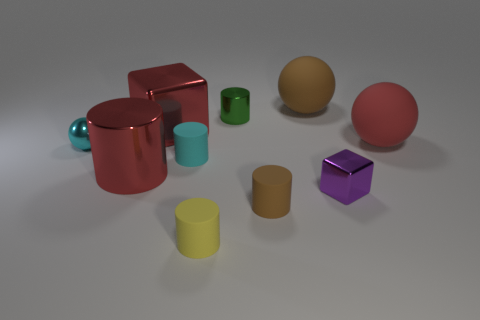Subtract all cyan cylinders. How many cylinders are left? 4 Subtract all cyan cylinders. How many cylinders are left? 4 Subtract all purple cylinders. Subtract all purple balls. How many cylinders are left? 5 Subtract all blocks. How many objects are left? 8 Subtract all big gray shiny cubes. Subtract all brown matte balls. How many objects are left? 9 Add 2 metal objects. How many metal objects are left? 7 Add 1 cyan rubber objects. How many cyan rubber objects exist? 2 Subtract 0 purple cylinders. How many objects are left? 10 